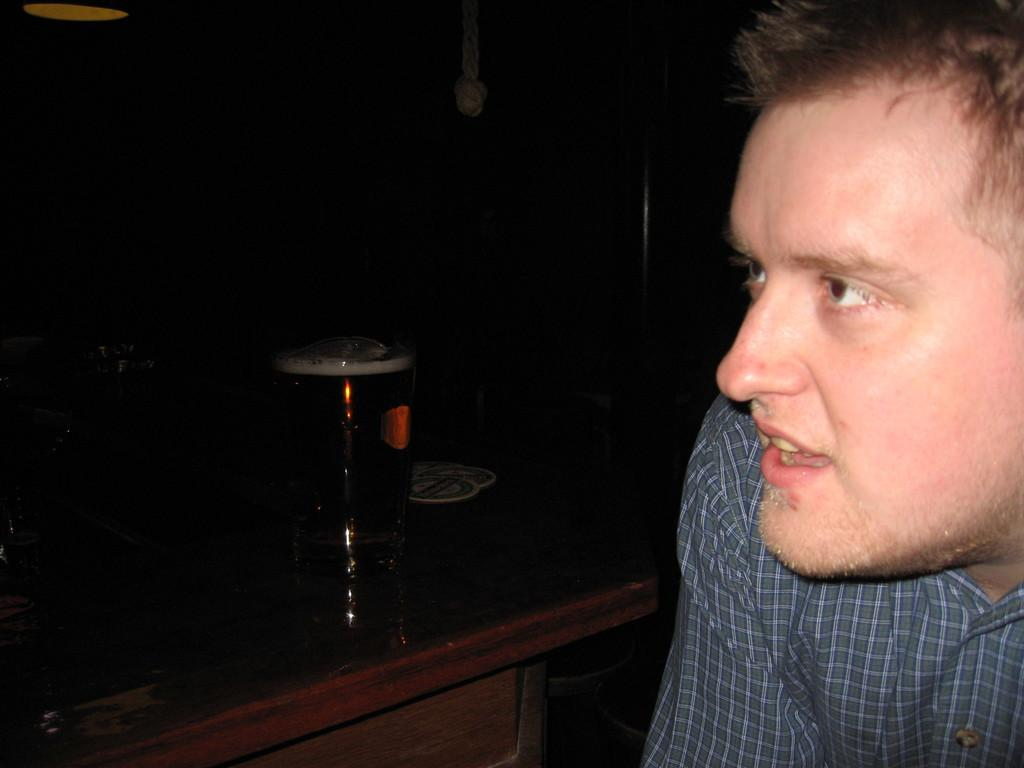What is the main subject of the image? The main subject of the image is a man. What is the man doing in the image? The man is sitting on a chair. What is located to the left side of the man? There is a table to the left side of the man. What can be seen on the table? There is a glass on the table. What color is the background of the image? The background of the man is in black color. What type of pipe is the man smoking in the image? There is no pipe present in the image; the man is not smoking. What kind of bears can be seen in the background of the image? There are no bears present in the image; the background is in black color. 